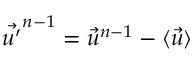<formula> <loc_0><loc_0><loc_500><loc_500>\vec { u ^ { \prime } } ^ { n - 1 } = \vec { u } ^ { n - 1 } - \langle \vec { u } \rangle</formula> 